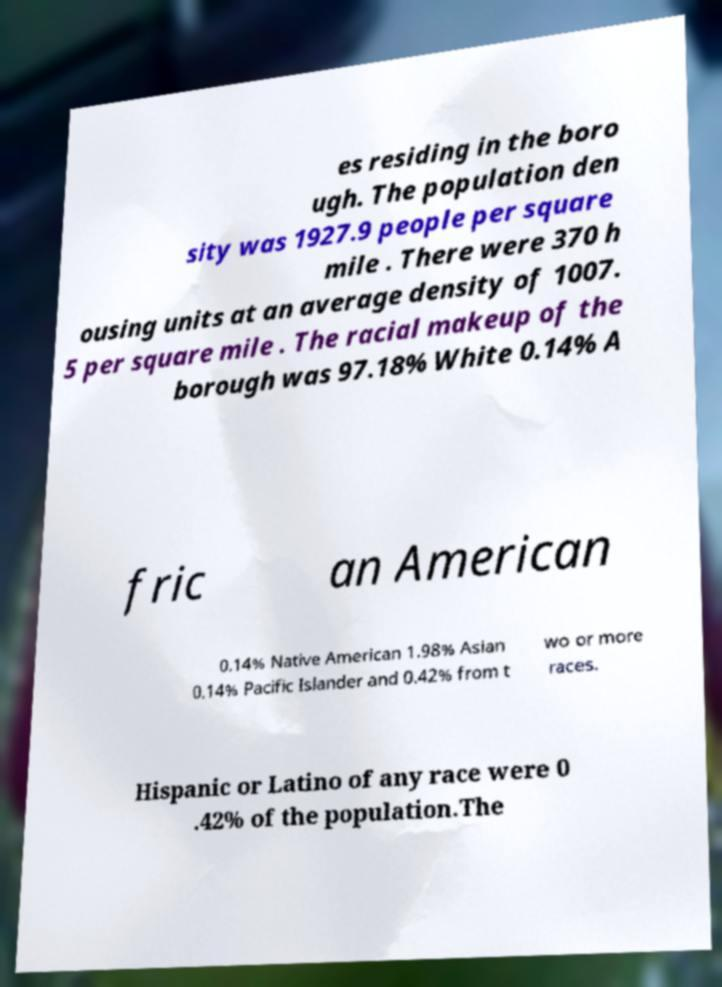Please read and relay the text visible in this image. What does it say? es residing in the boro ugh. The population den sity was 1927.9 people per square mile . There were 370 h ousing units at an average density of 1007. 5 per square mile . The racial makeup of the borough was 97.18% White 0.14% A fric an American 0.14% Native American 1.98% Asian 0.14% Pacific Islander and 0.42% from t wo or more races. Hispanic or Latino of any race were 0 .42% of the population.The 